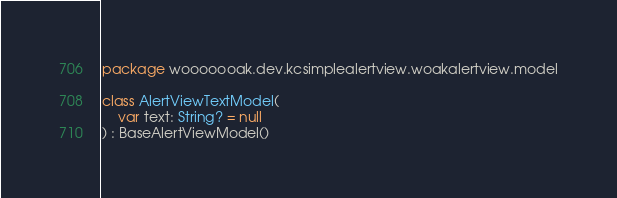<code> <loc_0><loc_0><loc_500><loc_500><_Kotlin_>package wooooooak.dev.kcsimplealertview.woakalertview.model

class AlertViewTextModel(
    var text: String? = null
) : BaseAlertViewModel()</code> 